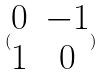<formula> <loc_0><loc_0><loc_500><loc_500>( \begin{matrix} 0 & - 1 \\ 1 & 0 \end{matrix} )</formula> 